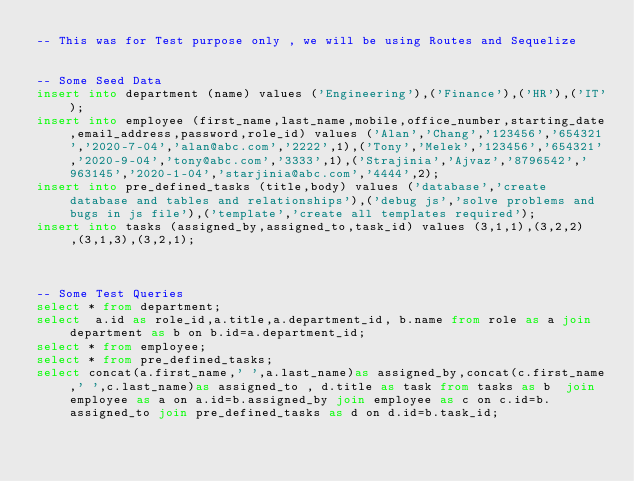Convert code to text. <code><loc_0><loc_0><loc_500><loc_500><_SQL_>-- This was for Test purpose only , we will be using Routes and Sequelize


-- Some Seed Data
insert into department (name) values ('Engineering'),('Finance'),('HR'),('IT');
insert into employee (first_name,last_name,mobile,office_number,starting_date,email_address,password,role_id) values ('Alan','Chang','123456','654321','2020-7-04','alan@abc.com','2222',1),('Tony','Melek','123456','654321','2020-9-04','tony@abc.com','3333',1),('Strajinia','Ajvaz','8796542','963145','2020-1-04','starjinia@abc.com','4444',2);
insert into pre_defined_tasks (title,body) values ('database','create database and tables and relationships'),('debug js','solve problems and bugs in js file'),('template','create all templates required');
insert into tasks (assigned_by,assigned_to,task_id) values (3,1,1),(3,2,2),(3,1,3),(3,2,1);



-- Some Test Queries
select * from department;
select  a.id as role_id,a.title,a.department_id, b.name from role as a join department as b on b.id=a.department_id;
select * from employee;
select * from pre_defined_tasks;
select concat(a.first_name,' ',a.last_name)as assigned_by,concat(c.first_name,' ',c.last_name)as assigned_to , d.title as task from tasks as b  join employee as a on a.id=b.assigned_by join employee as c on c.id=b.assigned_to join pre_defined_tasks as d on d.id=b.task_id;</code> 